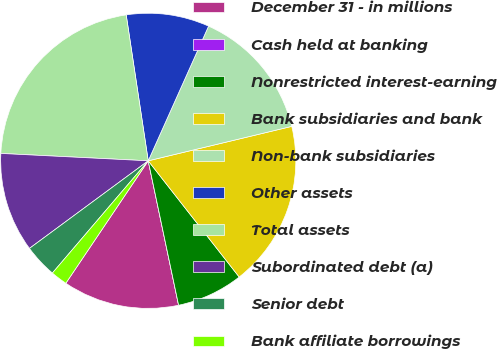<chart> <loc_0><loc_0><loc_500><loc_500><pie_chart><fcel>December 31 - in millions<fcel>Cash held at banking<fcel>Nonrestricted interest-earning<fcel>Bank subsidiaries and bank<fcel>Non-bank subsidiaries<fcel>Other assets<fcel>Total assets<fcel>Subordinated debt (a)<fcel>Senior debt<fcel>Bank affiliate borrowings<nl><fcel>12.73%<fcel>0.0%<fcel>7.27%<fcel>18.18%<fcel>14.55%<fcel>9.09%<fcel>21.82%<fcel>10.91%<fcel>3.64%<fcel>1.82%<nl></chart> 